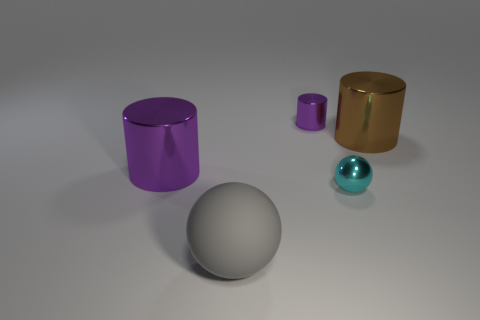What number of objects are either small brown objects or tiny purple objects?
Provide a succinct answer. 1. The large metallic object that is left of the large gray rubber thing has what shape?
Ensure brevity in your answer.  Cylinder. There is a ball that is made of the same material as the large brown cylinder; what color is it?
Keep it short and to the point. Cyan. There is a cyan object that is the same shape as the big gray thing; what is it made of?
Give a very brief answer. Metal. The large purple shiny object is what shape?
Make the answer very short. Cylinder. What material is the large thing that is both left of the cyan shiny ball and behind the small shiny ball?
Your answer should be very brief. Metal. The tiny cyan thing that is made of the same material as the large brown thing is what shape?
Your response must be concise. Sphere. There is a cyan sphere that is the same material as the tiny purple thing; what size is it?
Offer a very short reply. Small. The big object that is both on the left side of the brown cylinder and behind the tiny cyan shiny sphere has what shape?
Provide a succinct answer. Cylinder. What size is the metallic thing that is on the left side of the ball to the left of the cyan sphere?
Make the answer very short. Large. 